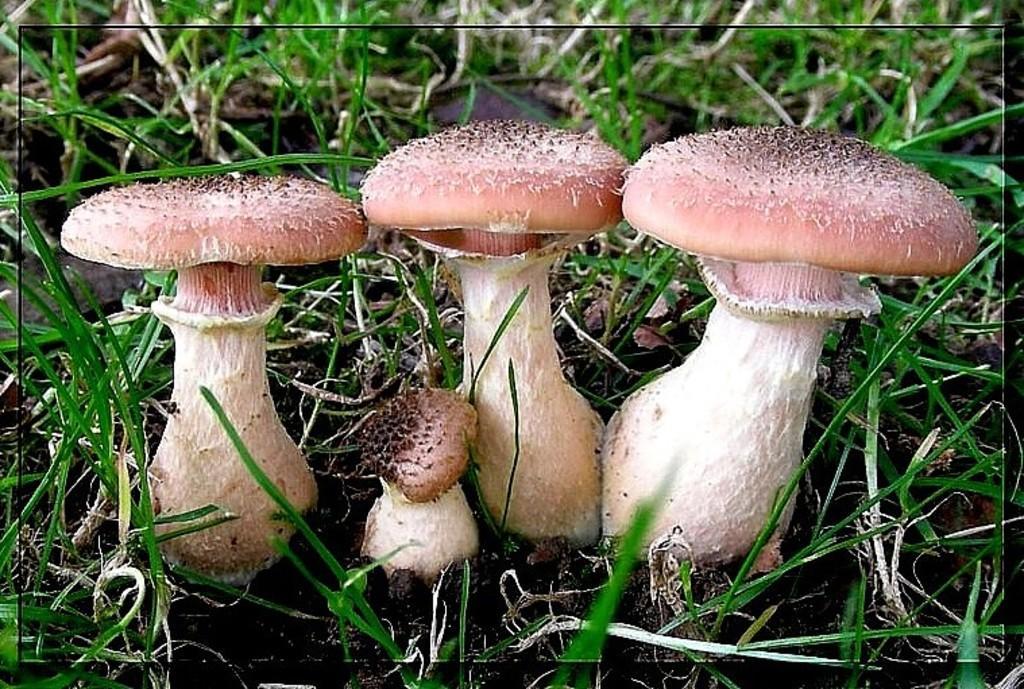Please provide a concise description of this image. In this image we can see some mushrooms and grass on the ground. 